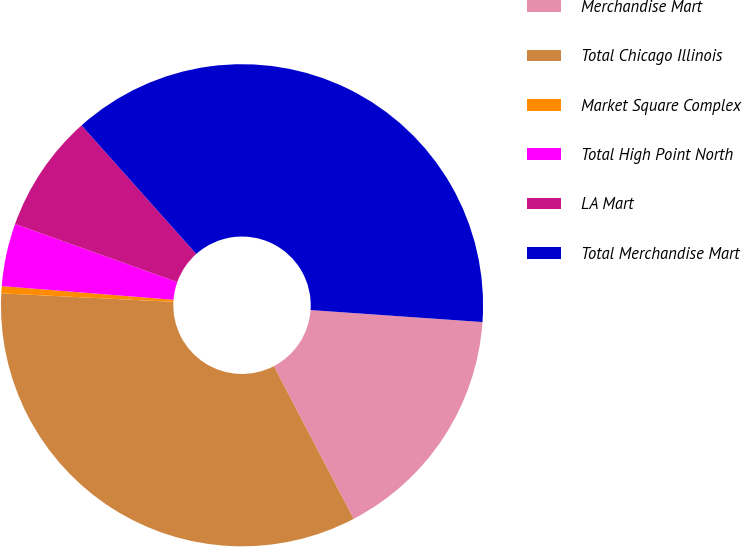<chart> <loc_0><loc_0><loc_500><loc_500><pie_chart><fcel>Merchandise Mart<fcel>Total Chicago Illinois<fcel>Market Square Complex<fcel>Total High Point North<fcel>LA Mart<fcel>Total Merchandise Mart<nl><fcel>16.23%<fcel>33.45%<fcel>0.48%<fcel>4.21%<fcel>7.93%<fcel>37.71%<nl></chart> 